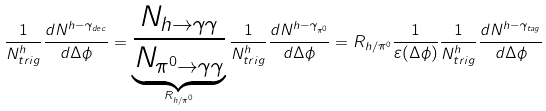<formula> <loc_0><loc_0><loc_500><loc_500>\frac { 1 } { N ^ { h } _ { t r i g } } \frac { d N ^ { h - \gamma _ { d e c } } } { d \Delta \phi } = \underbrace { \frac { N _ { h \rightarrow \gamma \gamma } } { N _ { \pi ^ { 0 } \rightarrow \gamma \gamma } } } _ { R _ { h / \pi ^ { 0 } } } \frac { 1 } { N ^ { h } _ { t r i g } } \frac { d N ^ { h - \gamma _ { \pi ^ { 0 } } } } { d \Delta \phi } = R _ { h / \pi ^ { 0 } } \frac { 1 } { \varepsilon ( \Delta \phi ) } \frac { 1 } { N ^ { h } _ { t r i g } } \frac { d N ^ { h - \gamma _ { t a g } } } { d \Delta \phi }</formula> 